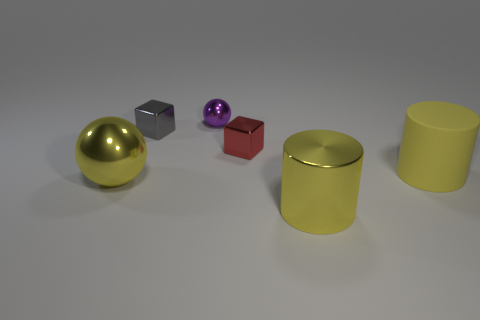There is a sphere that is behind the small cube to the left of the tiny red object; what size is it?
Offer a terse response. Small. Do the large yellow ball and the cylinder that is on the left side of the large yellow matte cylinder have the same material?
Your answer should be compact. Yes. Is the number of red cubes behind the red metallic object less than the number of large yellow metallic balls in front of the tiny gray thing?
Keep it short and to the point. Yes. What is the color of the other tiny ball that is the same material as the yellow ball?
Give a very brief answer. Purple. Is there a metallic sphere that is to the right of the tiny purple metallic thing that is behind the large yellow ball?
Provide a succinct answer. No. What is the color of the sphere that is the same size as the yellow rubber cylinder?
Provide a short and direct response. Yellow. What number of objects are metallic balls or big yellow rubber things?
Your response must be concise. 3. How big is the yellow thing right of the metallic object that is in front of the metal ball in front of the purple shiny sphere?
Keep it short and to the point. Large. What number of small rubber balls are the same color as the big shiny ball?
Make the answer very short. 0. How many small gray cylinders are made of the same material as the small red thing?
Your response must be concise. 0. 